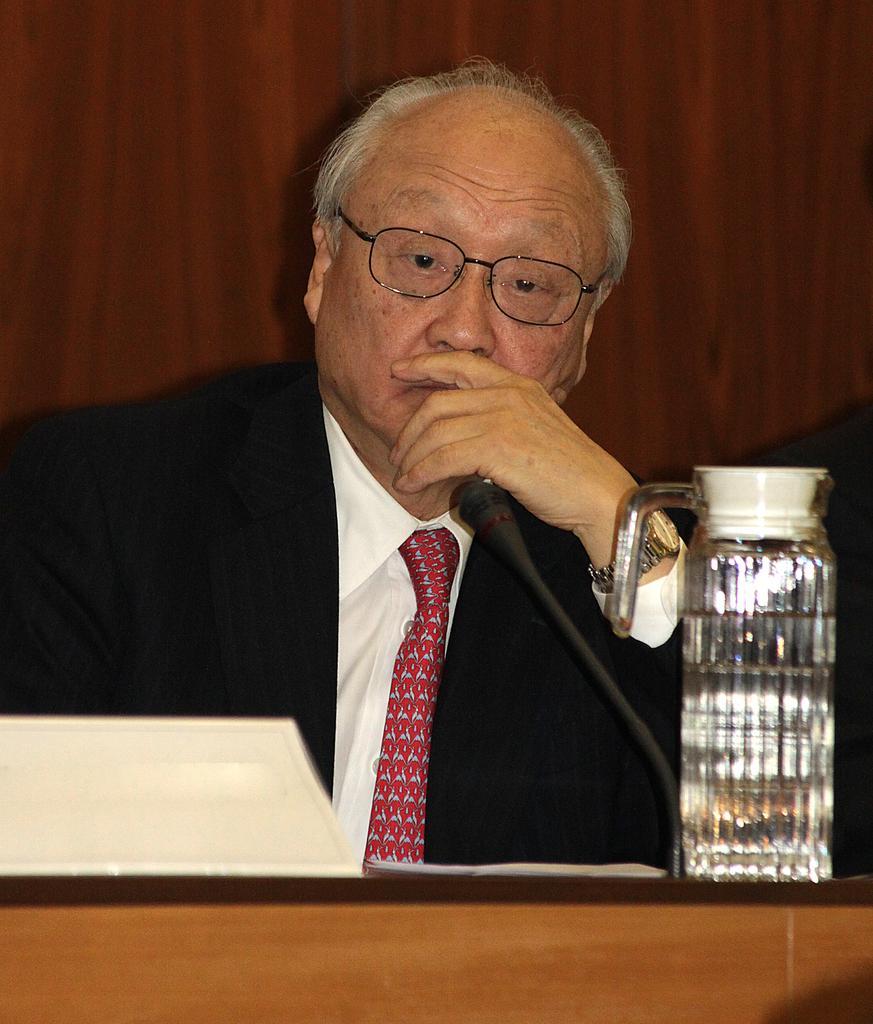Please provide a concise description of this image. This is an old man sitting. He wore a shirt, tie, suit and spectacle. This is a table with a water jug, mike, paper and few other things on it. In the background, that looks like a wooden board. 